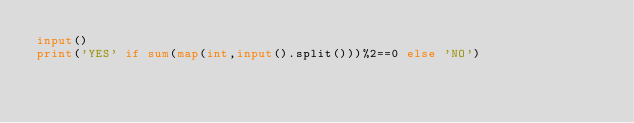<code> <loc_0><loc_0><loc_500><loc_500><_Python_>input()
print('YES' if sum(map(int,input().split()))%2==0 else 'NO')</code> 